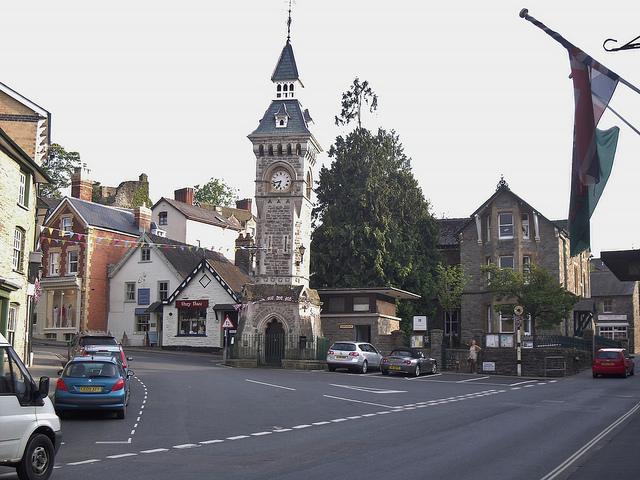How many red cars do you see?
Concise answer only. 1. What time is it according to the street facing clock?
Answer briefly. 8:35. How many cars are in the picture?
Answer briefly. 7. 